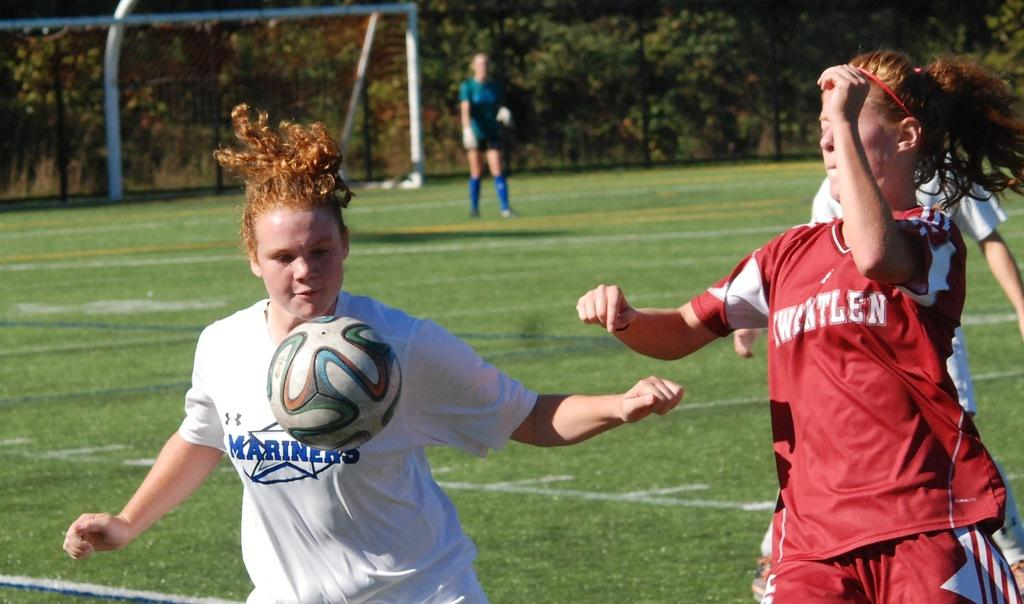What are the three people in the image doing? The three people in the image are playing football. What object is essential for playing football in the image? There is a ball in the image. Can you describe the background of the image? There is a lady standing in the background of the image, along with a net and trees. What type of servant is attending to the queen in the image? There is no queen or servant present in the image; it features three people playing football. What message of peace is being conveyed in the image? There is no message of peace being conveyed in the image; it shows people playing football. 